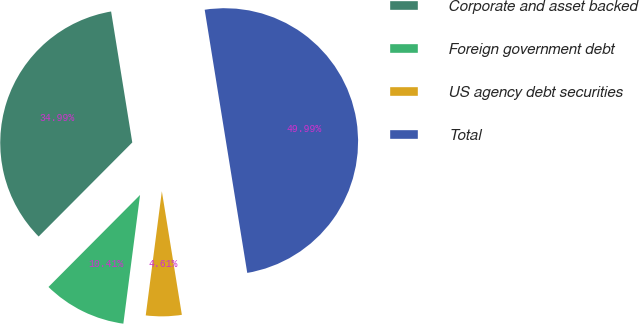<chart> <loc_0><loc_0><loc_500><loc_500><pie_chart><fcel>Corporate and asset backed<fcel>Foreign government debt<fcel>US agency debt securities<fcel>Total<nl><fcel>34.99%<fcel>10.41%<fcel>4.61%<fcel>50.0%<nl></chart> 